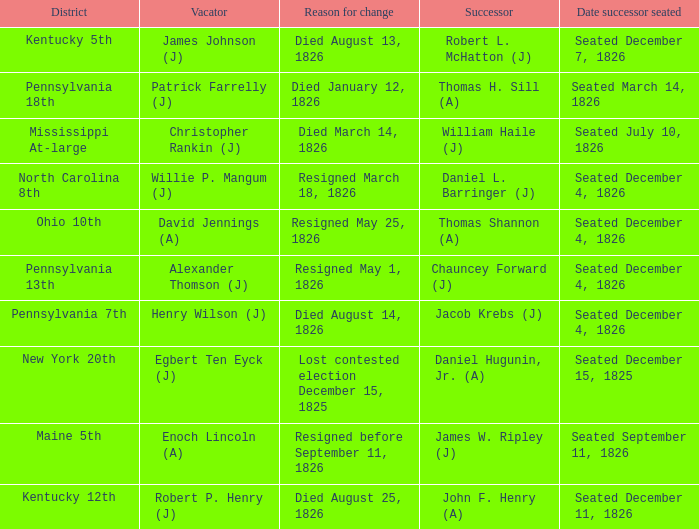Name the vacator for died august 13, 1826 James Johnson (J). 